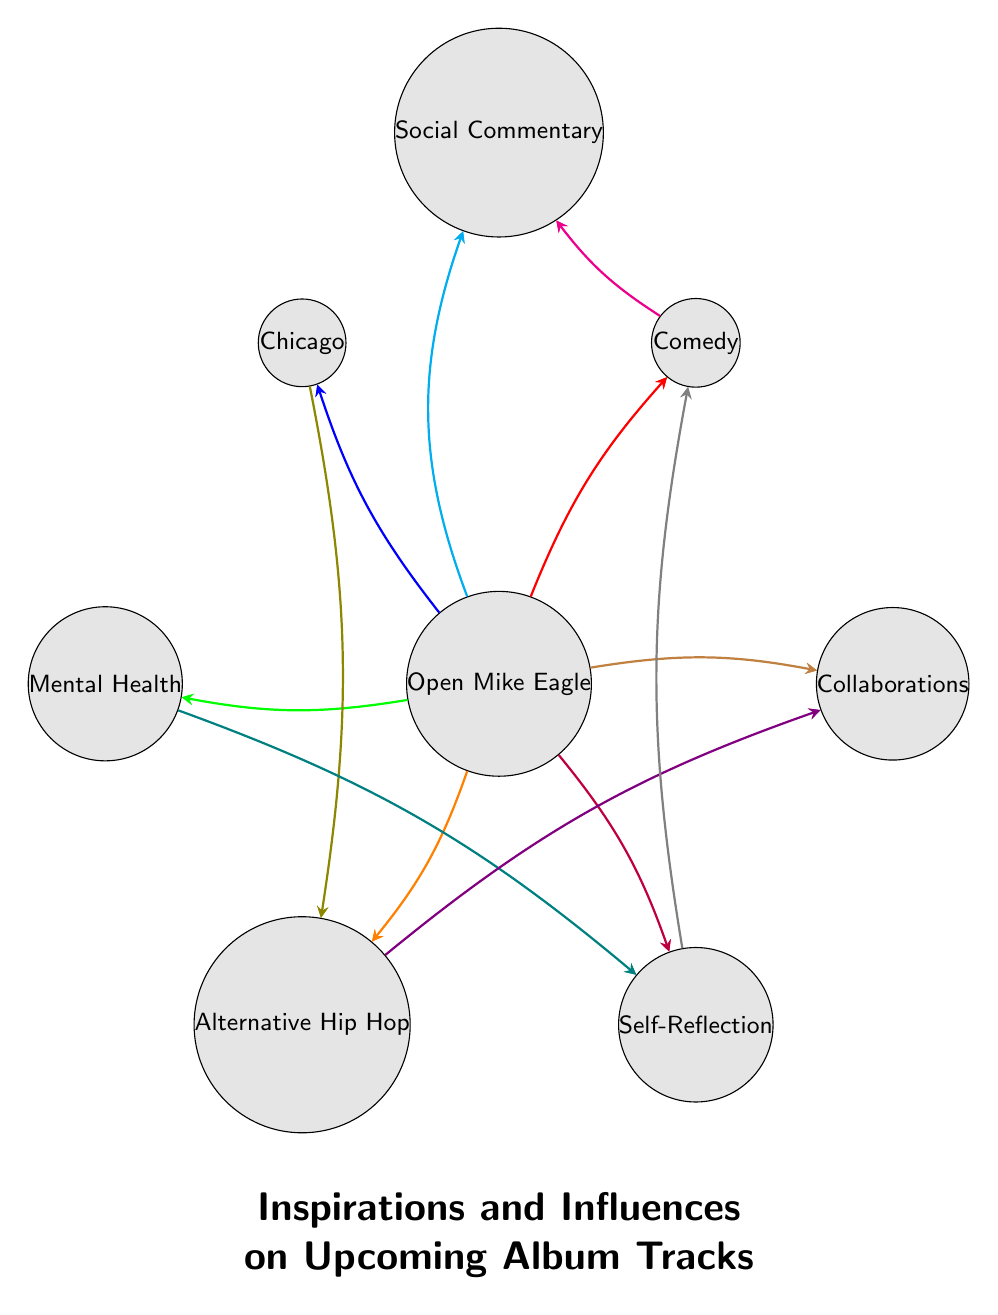What is the total number of nodes in the diagram? The diagram lists eight specific nodes: Open Mike Eagle, Comedy, Chicago, Mental Health, Alternative Hip Hop, Self-Reflection, Collaborations, and Social Commentary. Counting these gives a total of eight nodes.
Answer: 8 Which node has the most connections? By examining the connections, it's clear that Open Mike Eagle is attached to all other nodes, totaling seven connections. This makes it the most connected node in the diagram.
Answer: Open Mike Eagle What relationship exists between Comedy and Social Commentary? The diagram shows a direct arrow connecting Comedy to Social Commentary, indicating that there is a relationship between these two nodes.
Answer: Direct connection How many connections does Mental Health have? Mental Health is connected to two nodes: Open Mike Eagle and Self-Reflection. Counting these connections gives two total connections.
Answer: 2 Which two nodes are connected through a collaboration? The node Alternative Hip Hop connects to Collaborations, indicating a connection related to work together or creative partnerships in that style.
Answer: Alternative Hip Hop and Collaborations What influences are linked to Self-Reflection? Self-Reflection has two direct influences in the diagram: it connects to Mental Health and Comedy. Thus, both of these contribute to Self-Reflection in some manner.
Answer: Mental Health, Comedy Is there a connection between Chicago and Social Commentary? There is no direct link between Chicago and Social Commentary in the diagram. The connections skip from Chicago to Alternative Hip Hop and then to its respective connections.
Answer: No What themes does Open Mike Eagle influence with his work? Open Mike Eagle influences Comedy, Chicago, Mental Health, Alternative Hip Hop, Self-Reflection, Collaborations, and Social Commentary. This indicates a broad range of themes he draws from.
Answer: Seven themes 